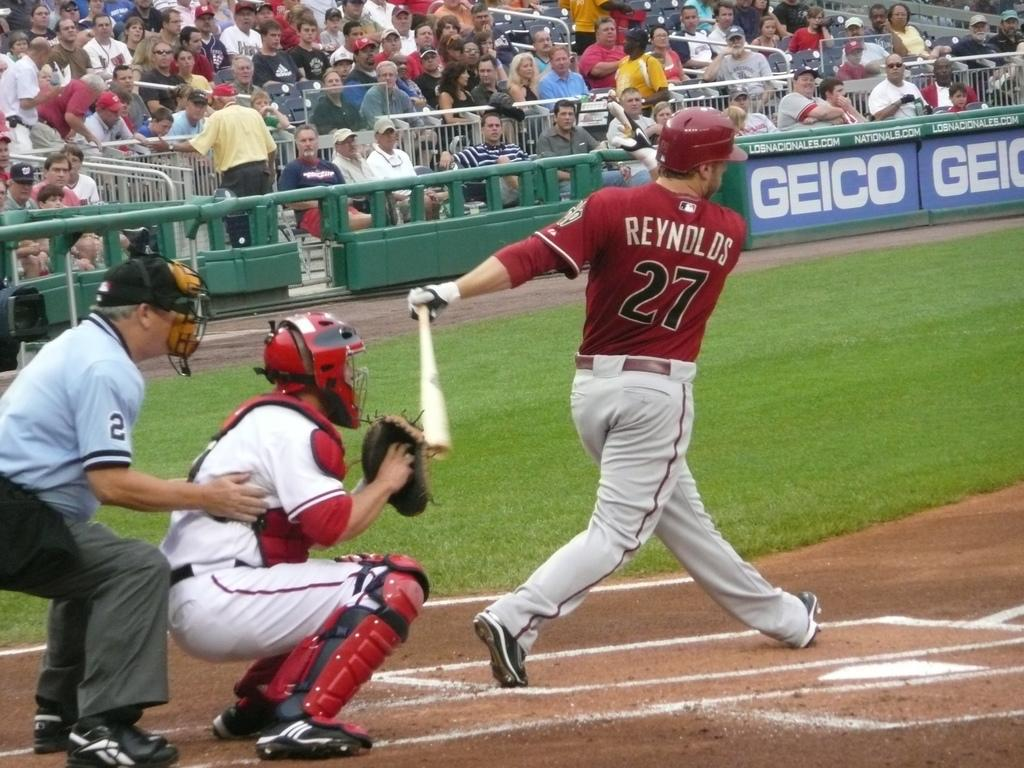<image>
Offer a succinct explanation of the picture presented. Strike for Reynolds as the catcher retrieves the ball from his glove. 